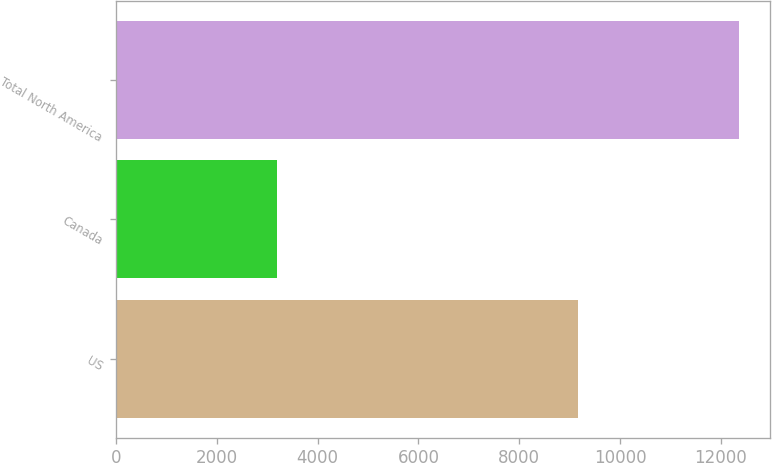Convert chart. <chart><loc_0><loc_0><loc_500><loc_500><bar_chart><fcel>US<fcel>Canada<fcel>Total North America<nl><fcel>9165<fcel>3195<fcel>12360<nl></chart> 